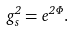<formula> <loc_0><loc_0><loc_500><loc_500>g _ { s } ^ { 2 } = e ^ { 2 \Phi } .</formula> 